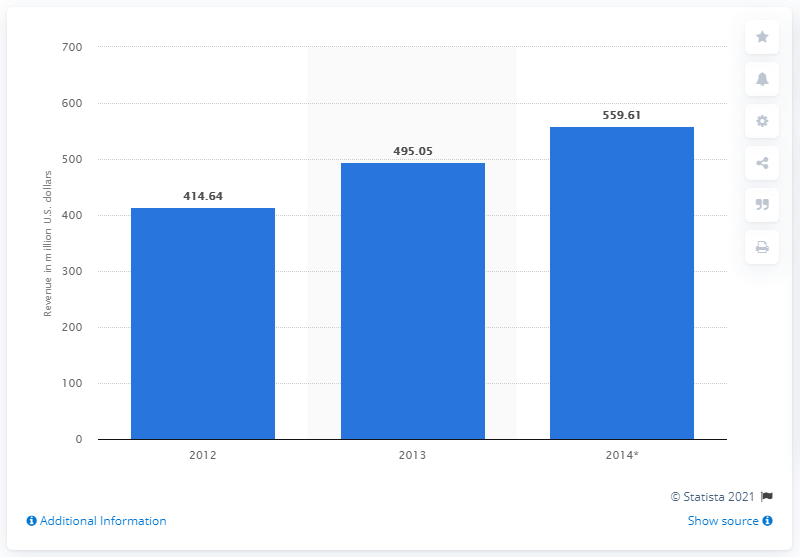Draw attention to some important aspects in this diagram. In 2014, the estimated revenue of Goodlife Fitness Canada was 559.61. 